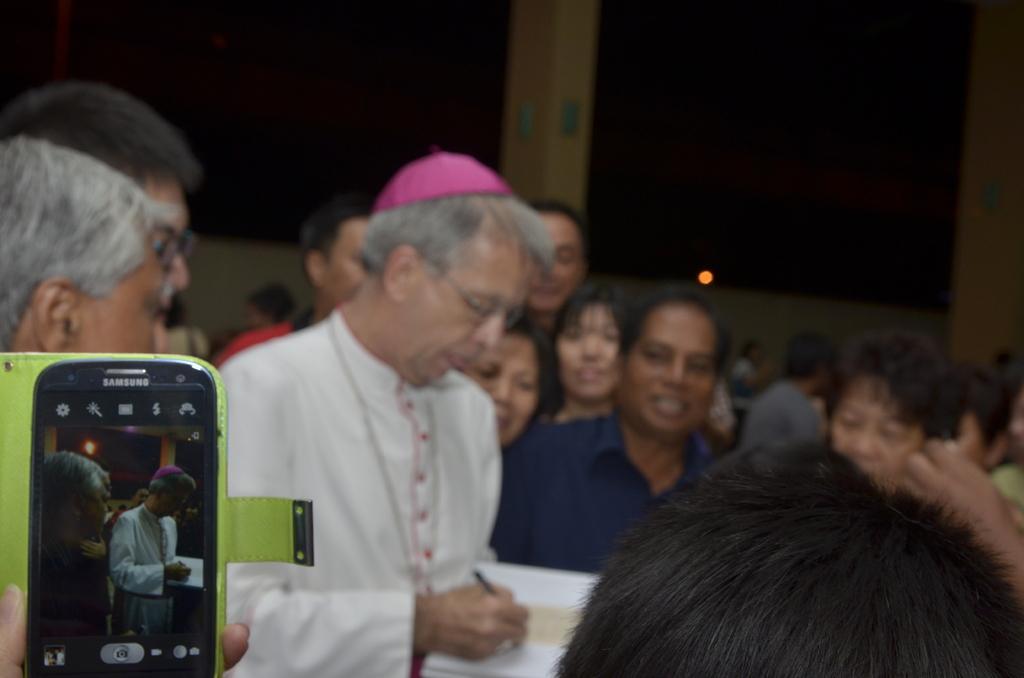Could you give a brief overview of what you see in this image? In this image I can see in the middle an old man is writing in the book, he wore white color dress and a pink color cap. On the left side there is the mobile phone, few people are there around him. 